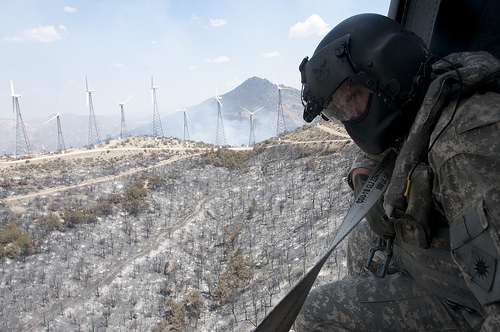<image>
Is there a soldier next to the wind generator? No. The soldier is not positioned next to the wind generator. They are located in different areas of the scene. 